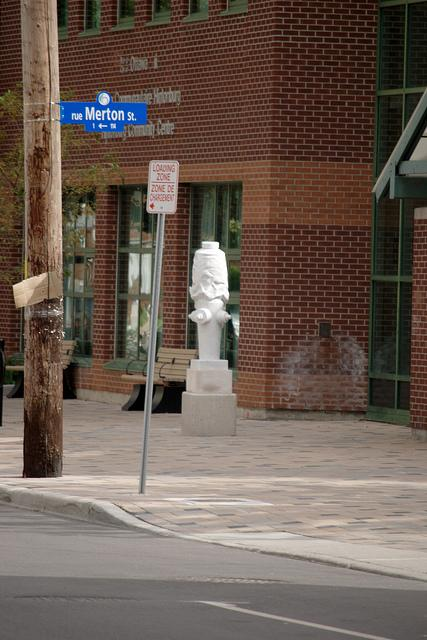The sculpture in front of the building is modeled after what common object found on a sidewalk? Please explain your reasoning. fire hydrant. It's made to look like a fire hydrant. 